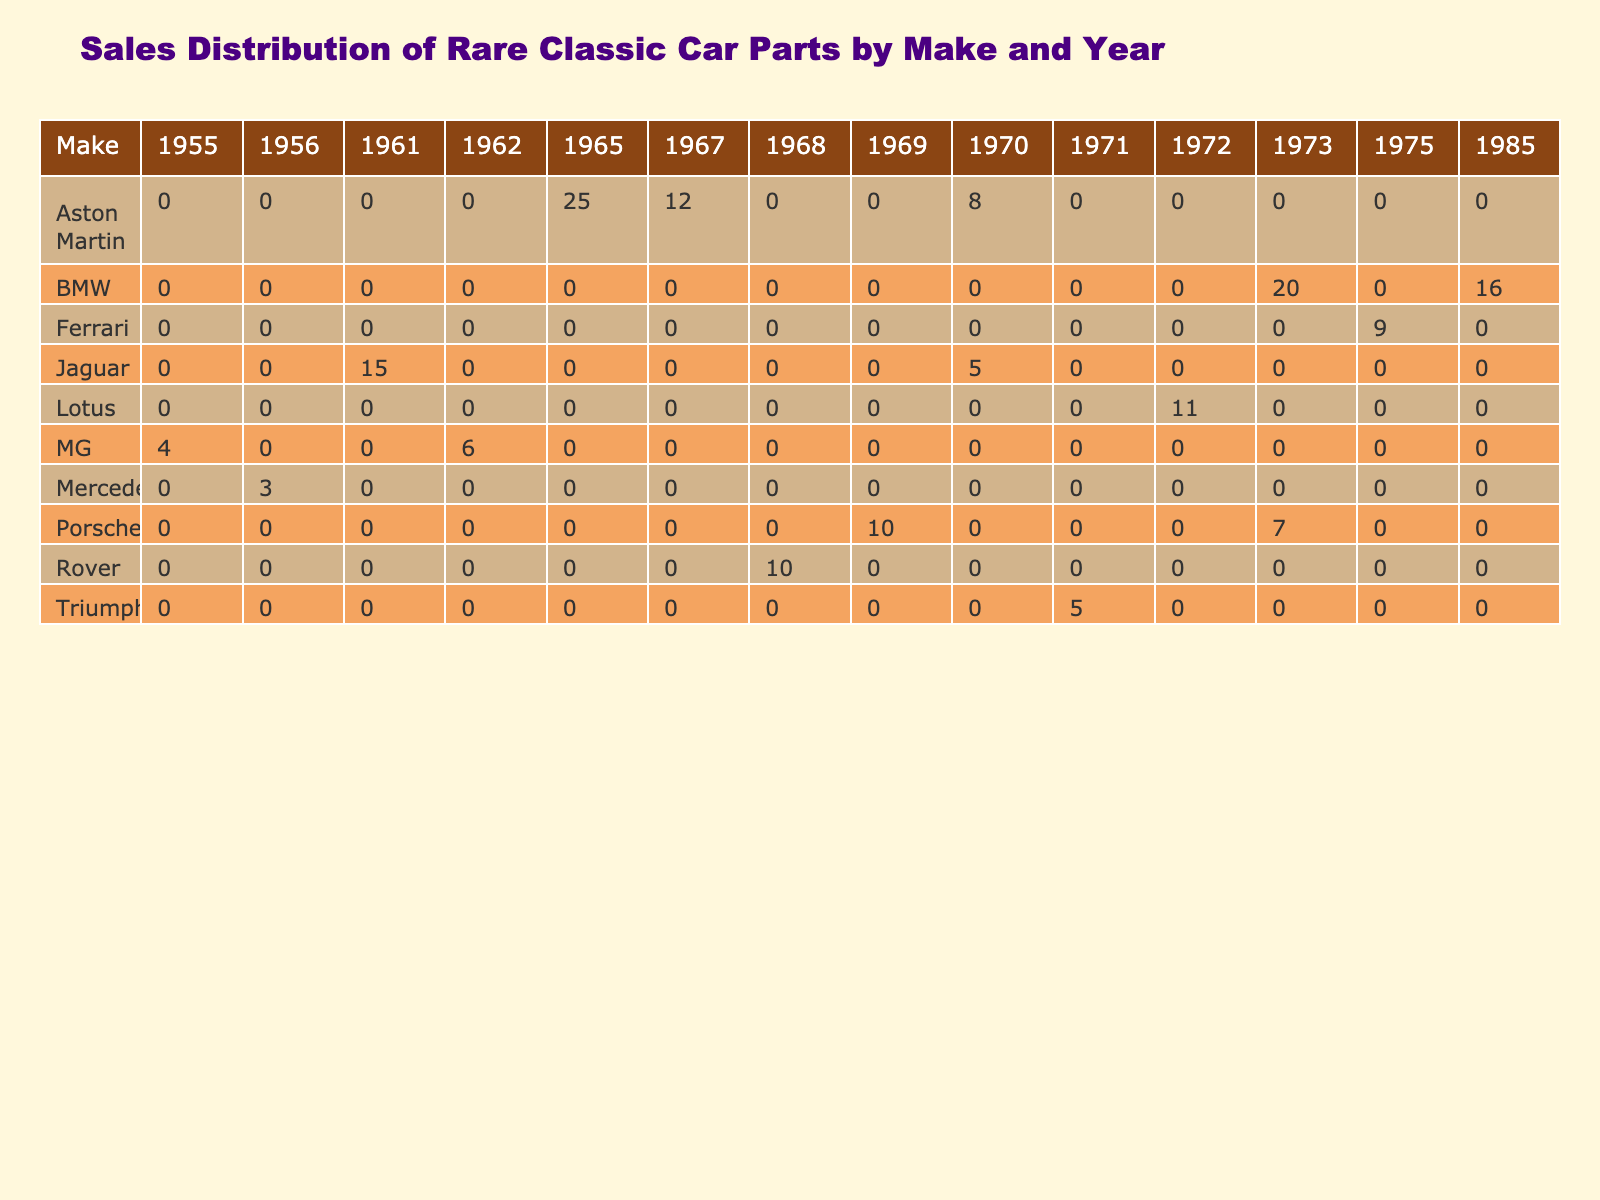What is the sales volume for Aston Martin in 1965? The table shows that the sales volume for Aston Martin in 1965 is listed in the corresponding row and column, which indicates a value of 25.
Answer: 25 Which make has the highest sales volume for parts in 1973? By examining the 1973 column, BMW has a sales volume of 20 and Porsche has a volume of 7. Therefore, the highest sales volume is from BMW.
Answer: BMW What is the total sales volume of parts for Jaguar across all years? To find the total for Jaguar, I add the sales volumes from each relevant year: 15 (1961) + 5 (1970) = 20.
Answer: 20 Did Ferrari have any sales in the year 1970? Reviewing the 1970 column, there is no entry for Ferrari, indicating that they did not sell any parts in that year.
Answer: No What is the average sales volume for parts across all makes in the year 1962? The only make listed for 1962 is MG with a sales volume of 6. As there is only one value, the average is simply that value: 6.
Answer: 6 Which two makes had sales volumes totaling more than 20 in the 1960s? First, we look at the 1960s total sales: Aston Martin (25+12=37), Jaguar (15+5=20), Porsche (10), and Rover (10). The two makes with totals exceeding 20 are Aston Martin and Jaguar.
Answer: Aston Martin, Jaguar What is the difference in sales volume between Aston Martin in 1965 and BMW in 1985? Aston Martin has a sales volume of 25 in 1965, while BMW has a volume of 16 in 1985. The difference is calculated as 25 - 16 = 9.
Answer: 9 Which make has the lowest total sales volume across all years? To determine the lowest total, I add all sales volumes for each make: Aston Martin (45), BMW (36), Porsche (17), Jaguar (20), and so forth. The lowest total is for Mercedes-Benz, which has 3.
Answer: Mercedes-Benz Are there any makes that have sales across all years listed in the table? I check for makes that appear in every year from the data presented. None have sales in every year, as they each only appear in specific years.
Answer: No 